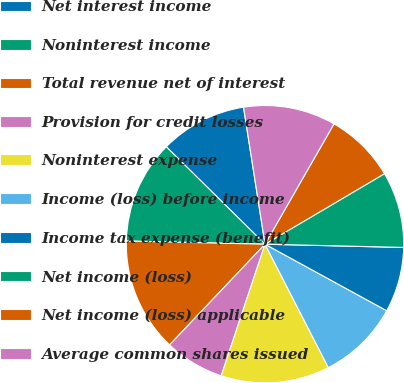Convert chart. <chart><loc_0><loc_0><loc_500><loc_500><pie_chart><fcel>Net interest income<fcel>Noninterest income<fcel>Total revenue net of interest<fcel>Provision for credit losses<fcel>Noninterest expense<fcel>Income (loss) before income<fcel>Income tax expense (benefit)<fcel>Net income (loss)<fcel>Net income (loss) applicable<fcel>Average common shares issued<nl><fcel>10.13%<fcel>12.03%<fcel>13.29%<fcel>6.96%<fcel>12.66%<fcel>9.49%<fcel>7.59%<fcel>8.86%<fcel>8.23%<fcel>10.76%<nl></chart> 